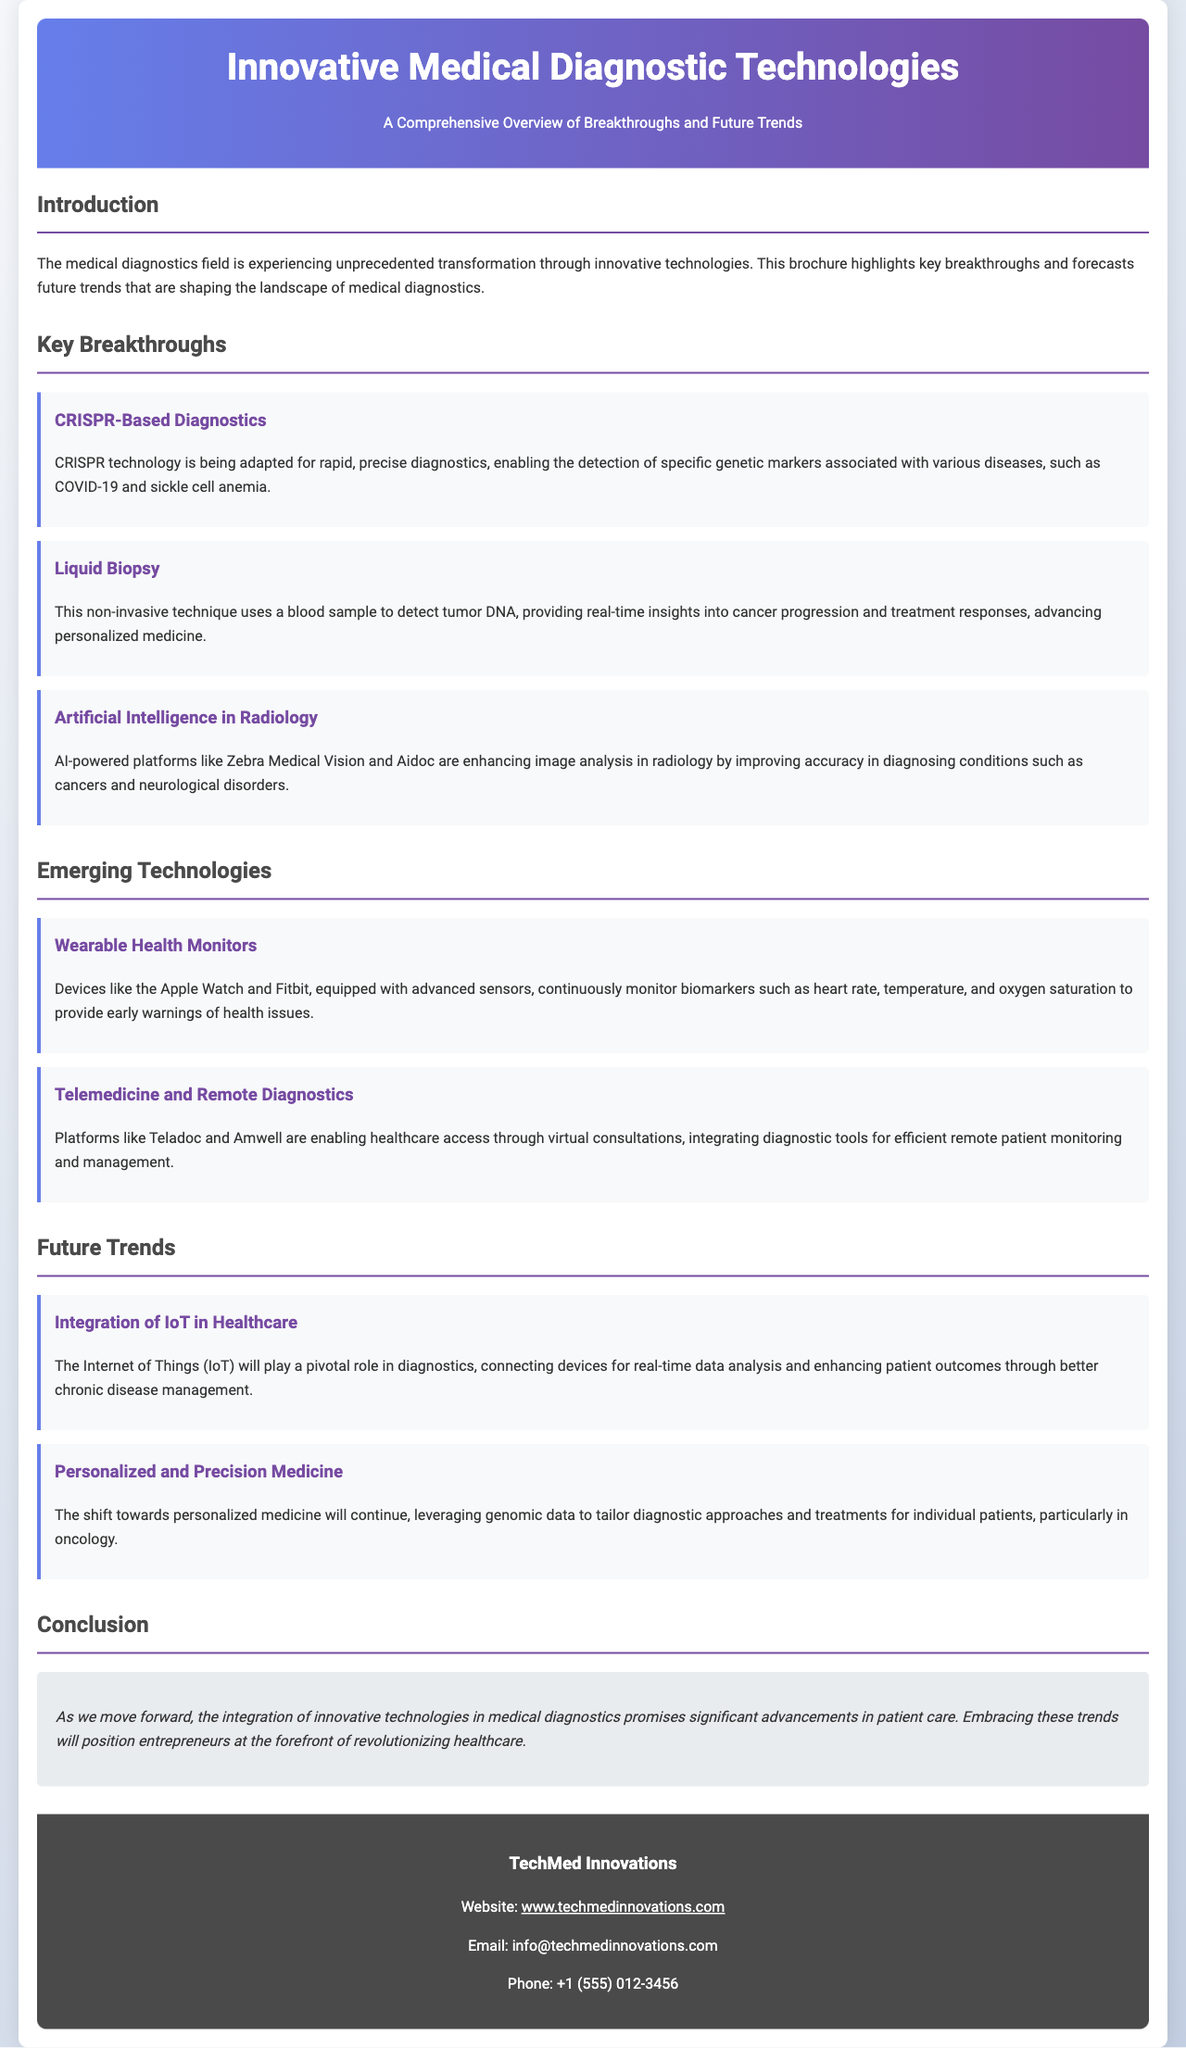What is the title of the brochure? The title is prominently displayed at the top of the document, indicating the main subject of the content.
Answer: Innovative Medical Diagnostic Technologies What technology is adapted for rapid diagnostics? The document mentions a specific breakthrough technology that is being utilized in the field of diagnostics.
Answer: CRISPR-Based Diagnostics Which non-invasive technique is mentioned for cancer detection? A specific method used to detect cancer through a blood sample is described in the breakthroughs section.
Answer: Liquid Biopsy What does AI enhance in radiology? The document specifies the particular area within radiology where AI technology is making significant improvements.
Answer: Image analysis Which device is known for continuous health monitoring? The brochure highlights popular devices that track various health parameters continuously.
Answer: Apple Watch What is a significant trend in healthcare according to the document? The future trends section identifies key movements shaping the future of medical diagnostics.
Answer: Integration of IoT in Healthcare What type of medicine is expected to be tailored to individual patients? The future trends discuss a specific approach to medicine that focuses on customizing treatment plans.
Answer: Personalized and Precision Medicine Which companies are mentioned for enabling virtual consultations? The text lists specific platforms that facilitate remote healthcare services.
Answer: Teladoc and Amwell What is emphasized in the conclusion of the brochure? The conclusion summarizes the overall importance of technological integration in improving healthcare.
Answer: Advancements in patient care 